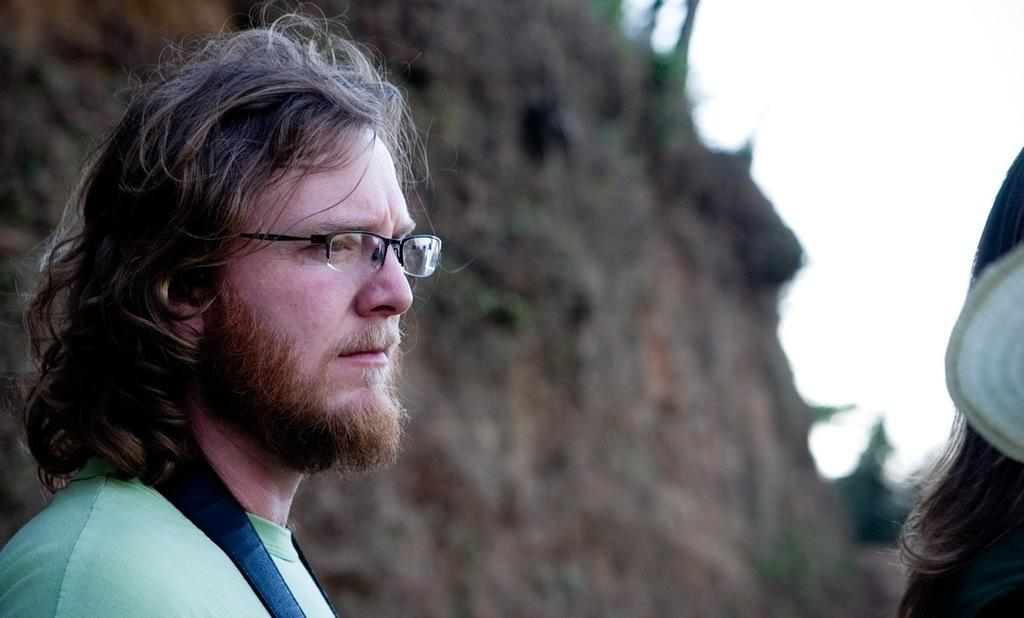Who is present in the image? There is a man in the image. What is the man wearing on his face? The man is wearing spectacles. Can you describe the hair visible in the image? There is hair visible on the right side of the image. What can be seen in the background of the image? The background of the image is blurry, and the sky is visible. What type of cloth is being used to cover the range in the image? There is no range or cloth present in the image. 